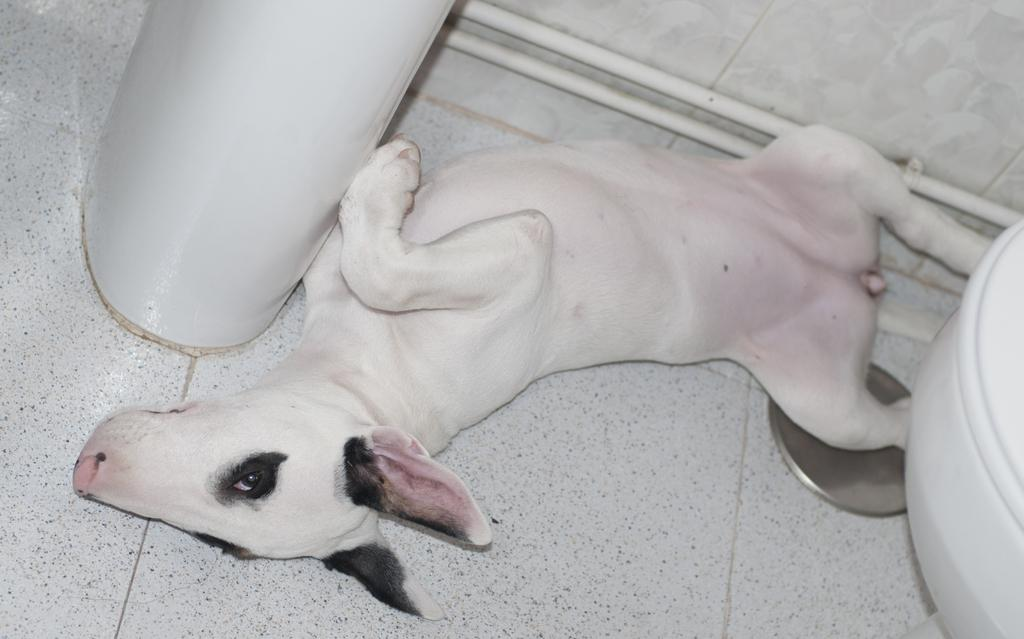What animal can be seen in the image? There is a dog in the image. Where is the dog located? The dog is laying on a path. What is in front of the dog? There is a pillar in front of the dog. What structures can be seen attached to a wall in the image? There are pipes attached to a wall in the image. What type of iron is being used by the dog in the image? There is no iron present in the image, and the dog is not using any iron. What time of day is depicted in the image? The time of day is not mentioned in the provided facts, so it cannot be determined from the image. 